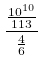<formula> <loc_0><loc_0><loc_500><loc_500>\frac { \frac { 1 0 ^ { 1 0 } } { 1 1 3 } } { \frac { 4 } { 6 } }</formula> 